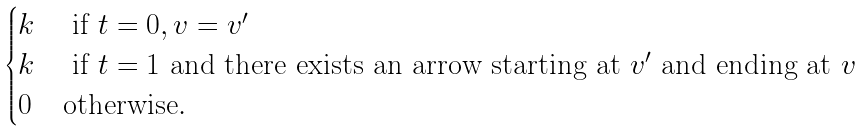Convert formula to latex. <formula><loc_0><loc_0><loc_500><loc_500>\begin{cases} k & \text { if } t = 0 , v = v ^ { \prime } \\ k & \text { if } t = 1 \text { and there exists an arrow starting at } v ^ { \prime } \text { and ending at } v \\ 0 & \text {otherwise} . \end{cases}</formula> 